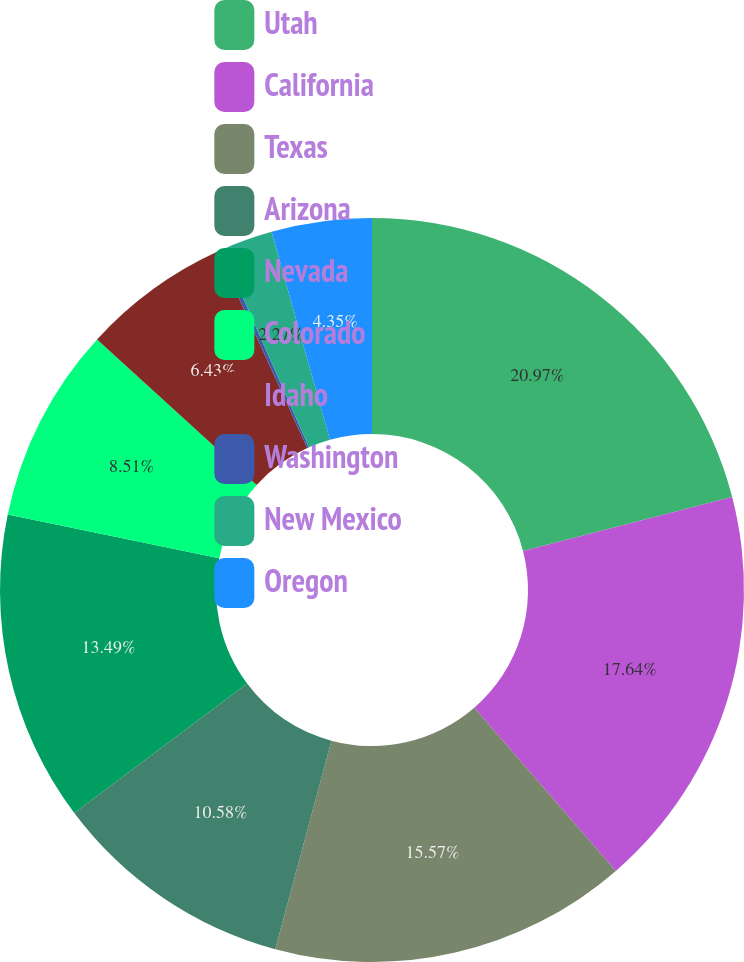Convert chart to OTSL. <chart><loc_0><loc_0><loc_500><loc_500><pie_chart><fcel>Utah<fcel>California<fcel>Texas<fcel>Arizona<fcel>Nevada<fcel>Colorado<fcel>Idaho<fcel>Washington<fcel>New Mexico<fcel>Oregon<nl><fcel>20.98%<fcel>17.65%<fcel>15.57%<fcel>10.58%<fcel>13.49%<fcel>8.51%<fcel>6.43%<fcel>0.19%<fcel>2.27%<fcel>4.35%<nl></chart> 